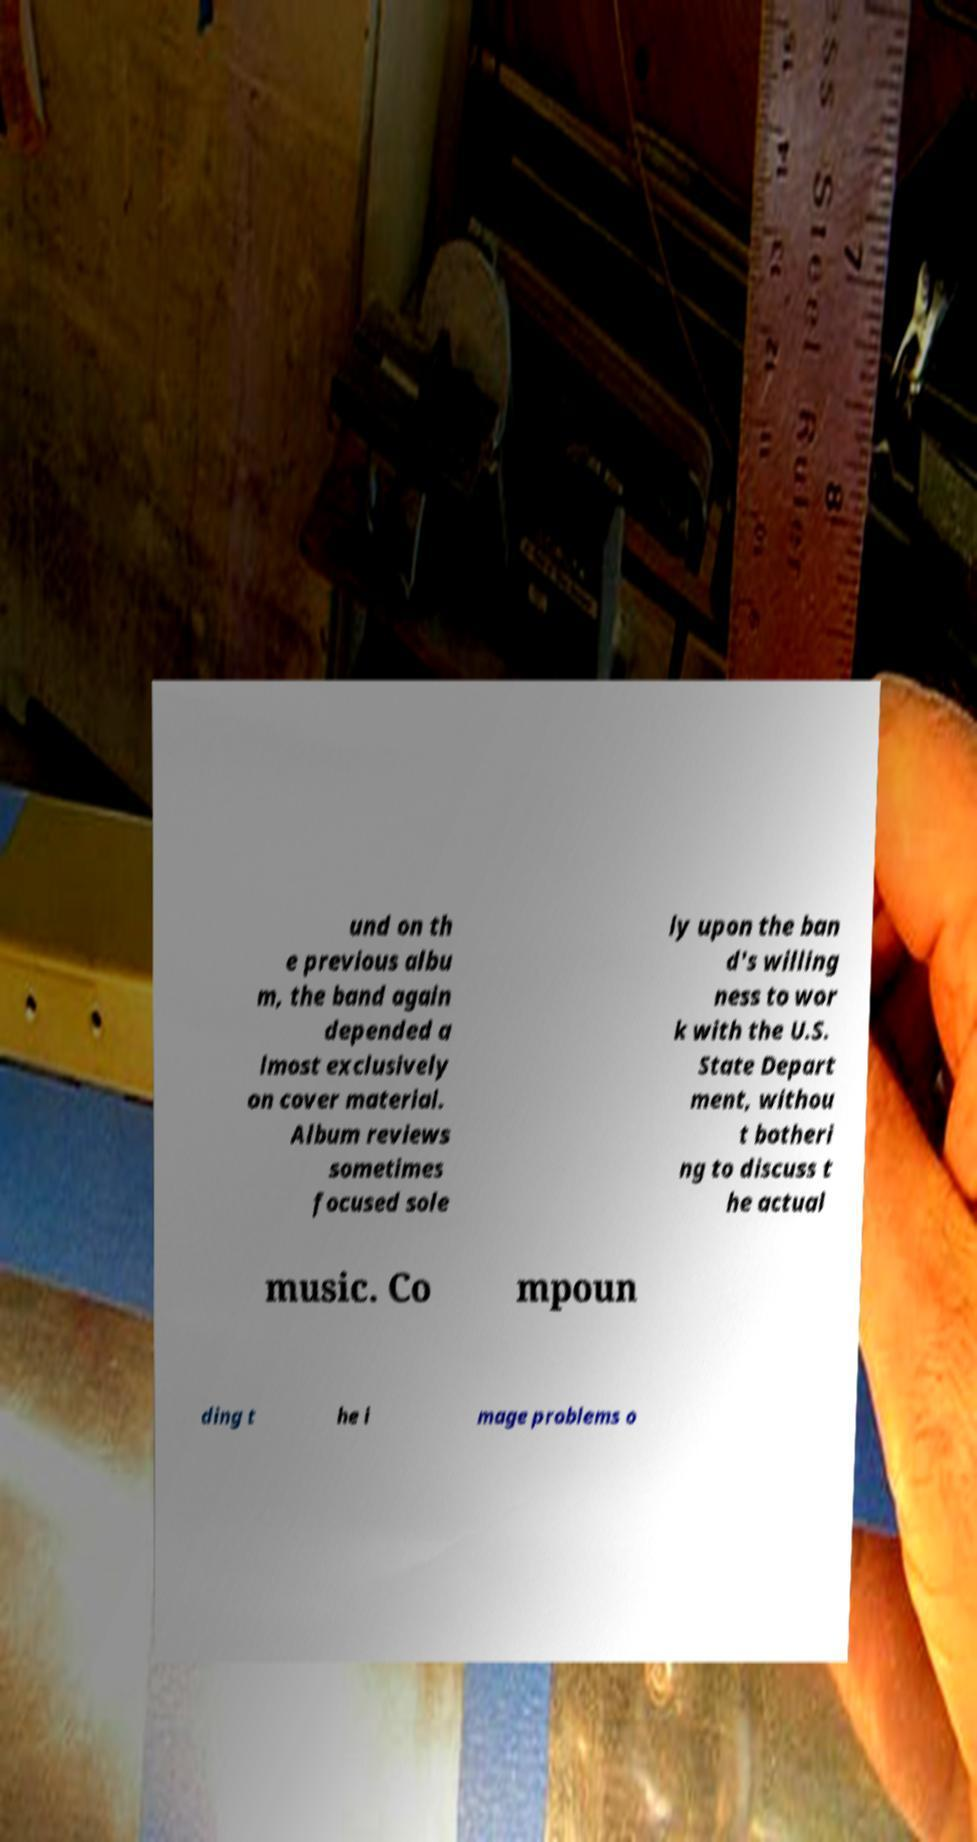For documentation purposes, I need the text within this image transcribed. Could you provide that? und on th e previous albu m, the band again depended a lmost exclusively on cover material. Album reviews sometimes focused sole ly upon the ban d's willing ness to wor k with the U.S. State Depart ment, withou t botheri ng to discuss t he actual music. Co mpoun ding t he i mage problems o 